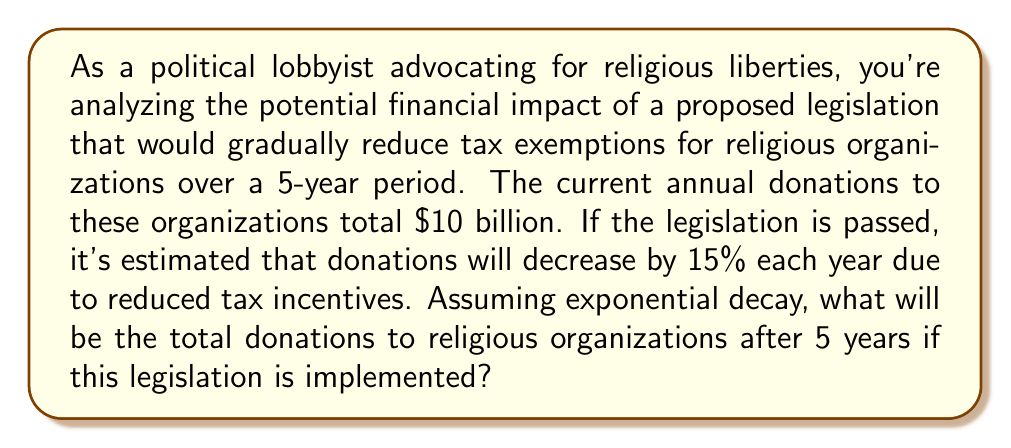Can you answer this question? To solve this problem, we'll use the exponential decay formula:

$$A = P(1-r)^t$$

Where:
$A$ = Final amount
$P$ = Initial principal balance
$r$ = Decay rate (as a decimal)
$t$ = Number of time periods

Given:
$P = \$10$ billion
$r = 15\% = 0.15$
$t = 5$ years

Step 1: Plug the values into the formula
$$A = 10(1-0.15)^5$$

Step 2: Simplify inside the parentheses
$$A = 10(0.85)^5$$

Step 3: Calculate the exponent
$$A = 10 \times 0.4437$$

Step 4: Multiply
$$A = 4.437$$

Therefore, after 5 years, the total donations will be approximately $4.437 billion.

To calculate the total financial impact, we need to find the difference between the initial and final amounts:

$$\text{Impact} = \text{Initial Amount} - \text{Final Amount}$$
$$\text{Impact} = \$10 \text{ billion} - \$4.437 \text{ billion}$$
$$\text{Impact} = \$5.563 \text{ billion}$$
Answer: The total donations to religious organizations after 5 years will be approximately $4.437 billion, representing a financial impact of $5.563 billion in reduced donations. 